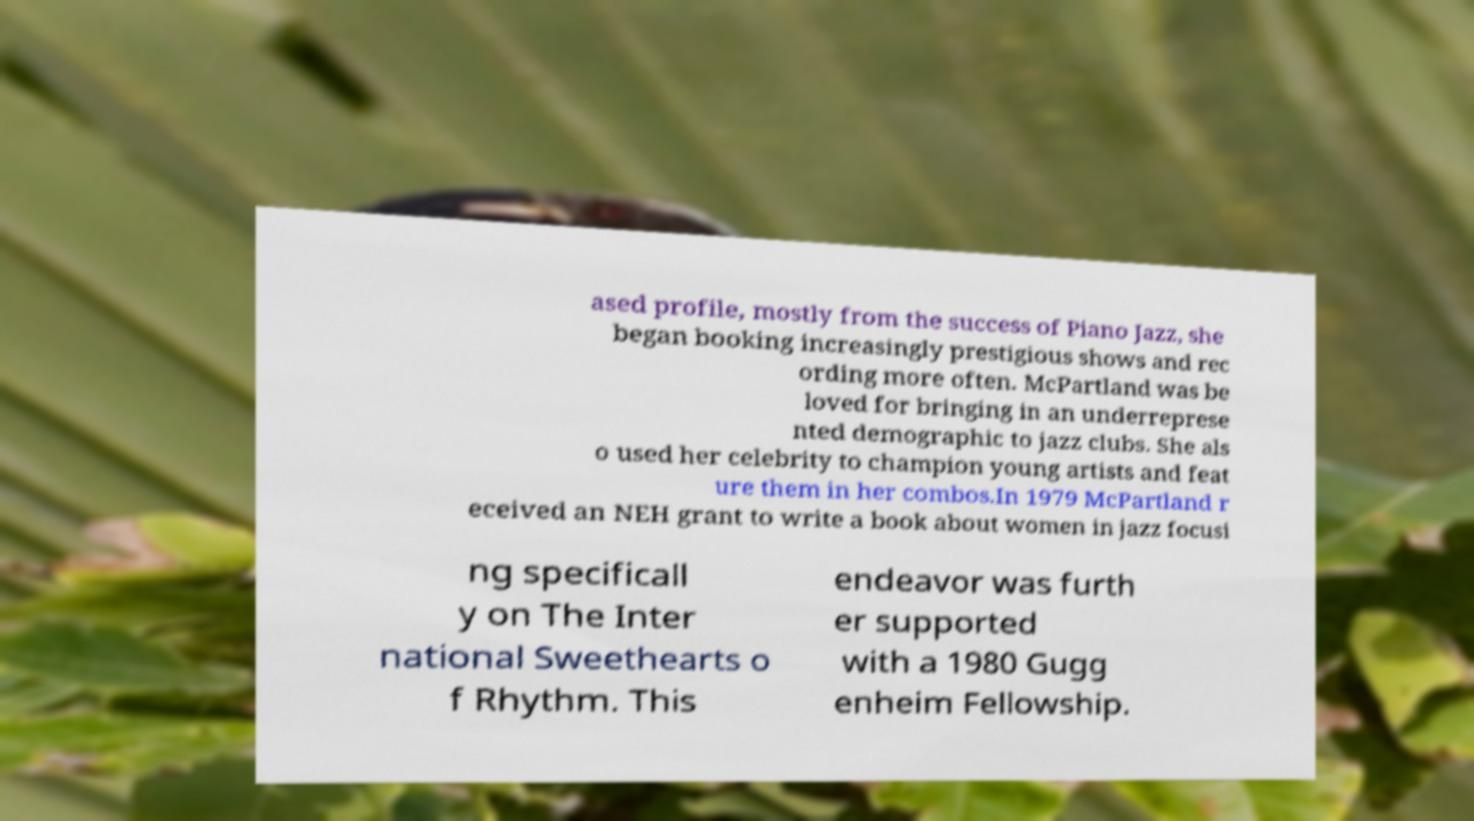Please read and relay the text visible in this image. What does it say? ased profile, mostly from the success of Piano Jazz, she began booking increasingly prestigious shows and rec ording more often. McPartland was be loved for bringing in an underreprese nted demographic to jazz clubs. She als o used her celebrity to champion young artists and feat ure them in her combos.In 1979 McPartland r eceived an NEH grant to write a book about women in jazz focusi ng specificall y on The Inter national Sweethearts o f Rhythm. This endeavor was furth er supported with a 1980 Gugg enheim Fellowship. 